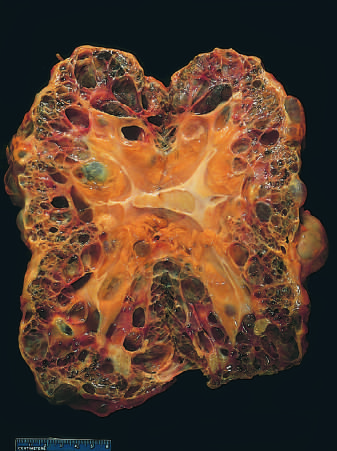what is markedly enlarged?
Answer the question using a single word or phrase. The kidney 